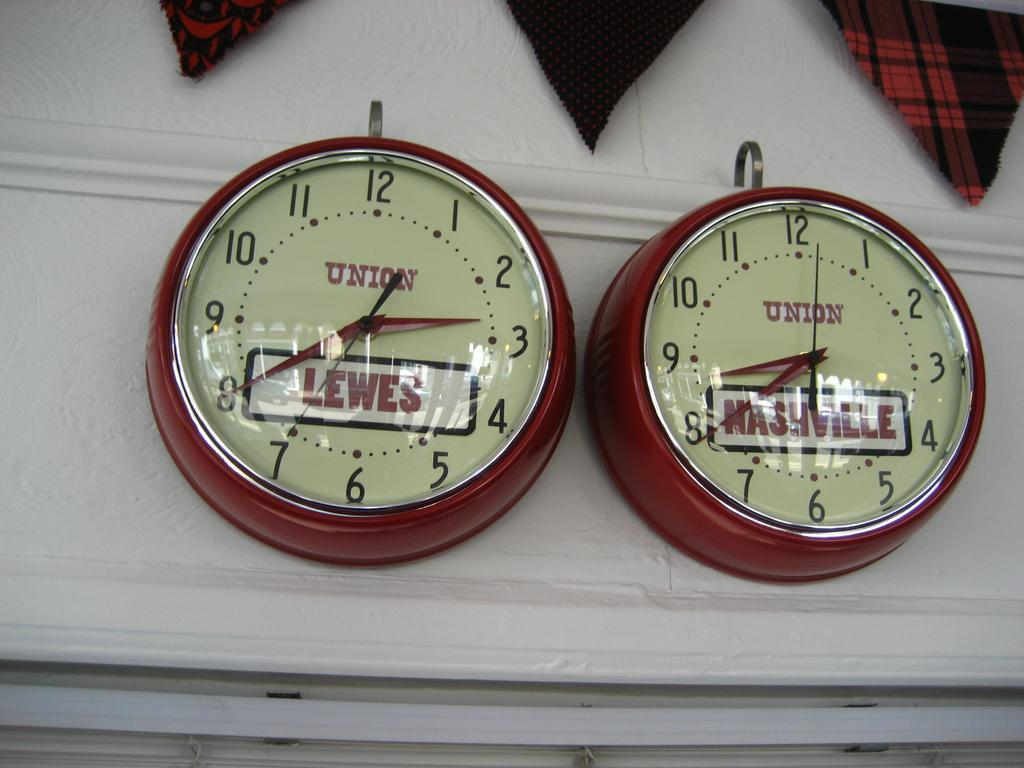Provide a one-sentence caption for the provided image. Two clocks are labeled with the word Union and city names. 